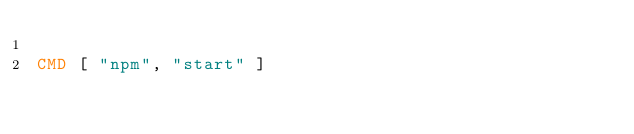<code> <loc_0><loc_0><loc_500><loc_500><_Dockerfile_>
CMD [ "npm", "start" ]
</code> 